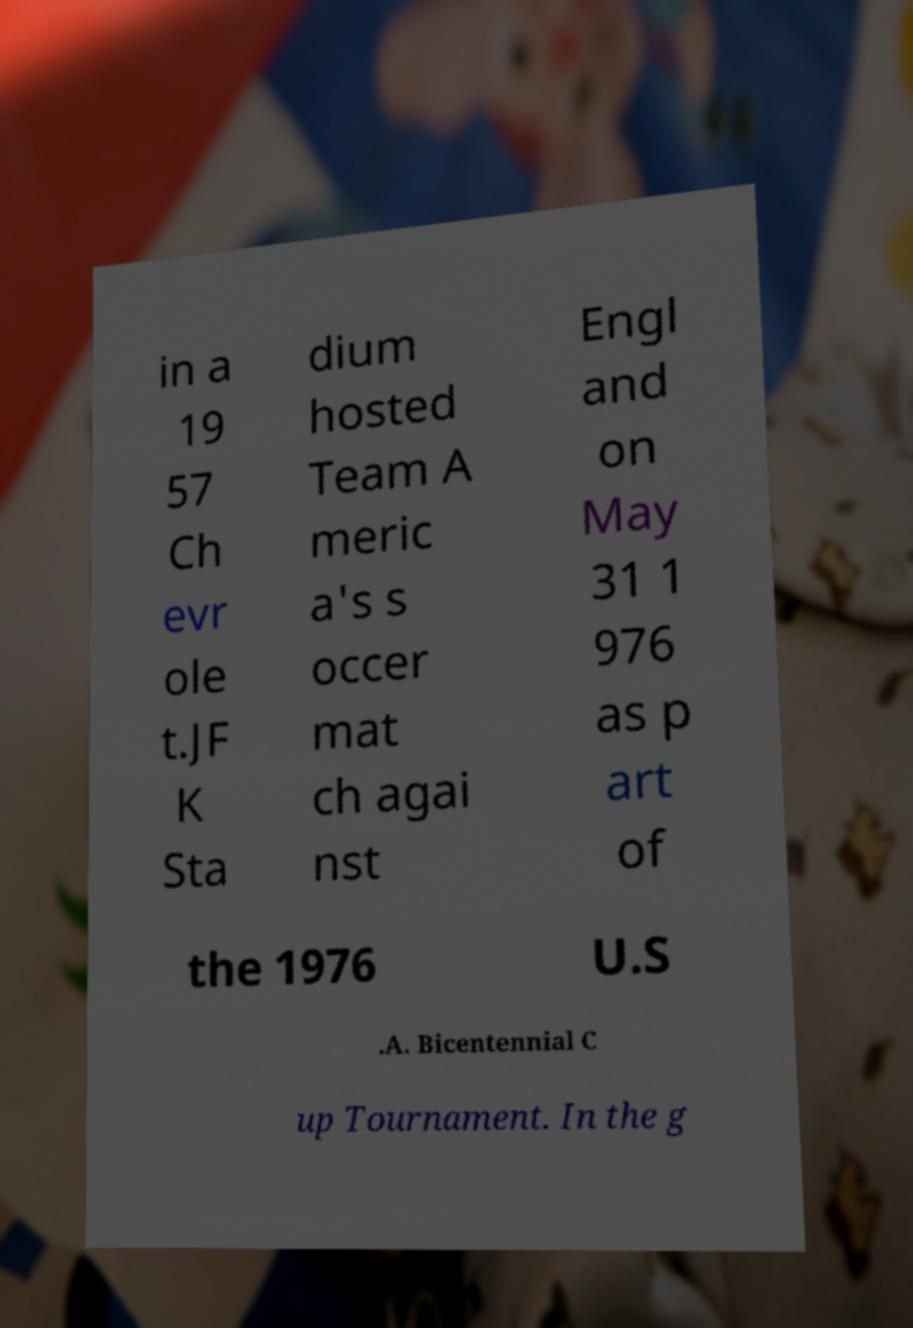Can you accurately transcribe the text from the provided image for me? in a 19 57 Ch evr ole t.JF K Sta dium hosted Team A meric a's s occer mat ch agai nst Engl and on May 31 1 976 as p art of the 1976 U.S .A. Bicentennial C up Tournament. In the g 